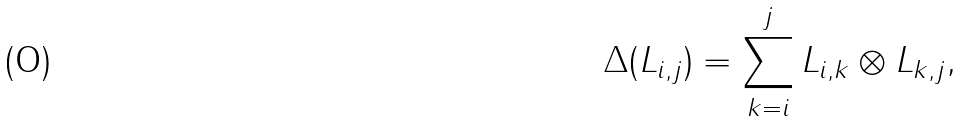Convert formula to latex. <formula><loc_0><loc_0><loc_500><loc_500>\Delta ( L _ { i , j } ) = \sum _ { k = i } ^ { j } L _ { i , k } \otimes L _ { k , j } ,</formula> 